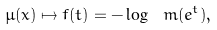<formula> <loc_0><loc_0><loc_500><loc_500>\mu ( x ) \mapsto f ( t ) = - \log \ m ( e ^ { t } ) ,</formula> 